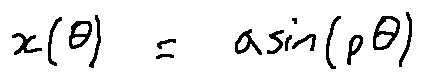Convert formula to latex. <formula><loc_0><loc_0><loc_500><loc_500>x ( \theta ) = a \sin ( p \theta )</formula> 